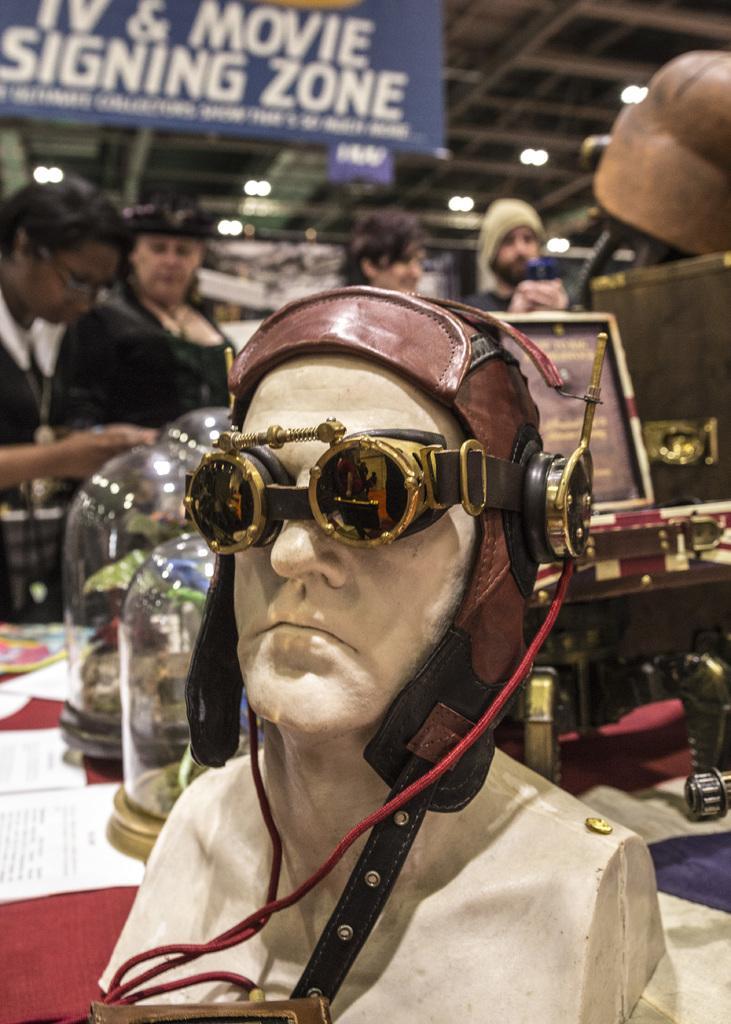In one or two sentences, can you explain what this image depicts? In this picture there are group of people standing and behind the table. In the foreground there is a sculpture of a person with helmet on the table. There are objects and there are papers on the table. At the top there is a hoarding and there is a text on the hoarding and there are lights. 